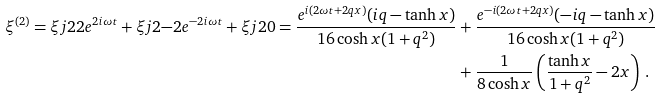Convert formula to latex. <formula><loc_0><loc_0><loc_500><loc_500>\xi ^ { ( 2 ) } = \xi j { 2 } { 2 } e ^ { 2 i \omega t } + \xi j { 2 } { - 2 } e ^ { - 2 i \omega t } + \xi j { 2 } { 0 } = \frac { e ^ { i ( 2 \omega t + 2 q x ) } ( i q - \tanh x ) } { 1 6 \cosh x ( 1 + q ^ { 2 } ) } & + \frac { e ^ { - i ( 2 \omega t + 2 q x ) } ( - i q - \tanh x ) } { 1 6 \cosh x ( 1 + q ^ { 2 } ) } \\ & + \frac { 1 } { 8 \cosh x } \left ( \frac { \tanh x } { 1 + q ^ { 2 } } - 2 x \right ) \, .</formula> 